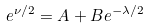<formula> <loc_0><loc_0><loc_500><loc_500>e ^ { \nu / 2 } = A + B e ^ { - \lambda / 2 }</formula> 